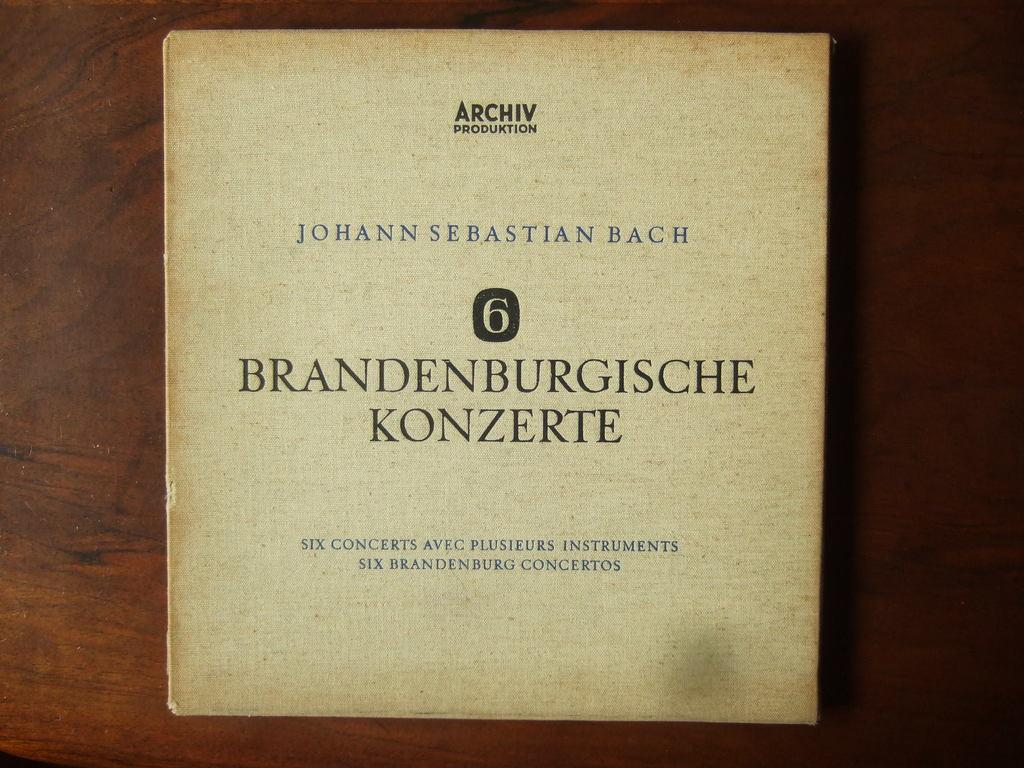<image>
Present a compact description of the photo's key features. An album cover of six Bach concerts written in a foreign language 